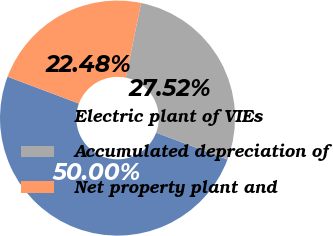<chart> <loc_0><loc_0><loc_500><loc_500><pie_chart><fcel>Electric plant of VIEs<fcel>Accumulated depreciation of<fcel>Net property plant and<nl><fcel>50.0%<fcel>27.52%<fcel>22.48%<nl></chart> 